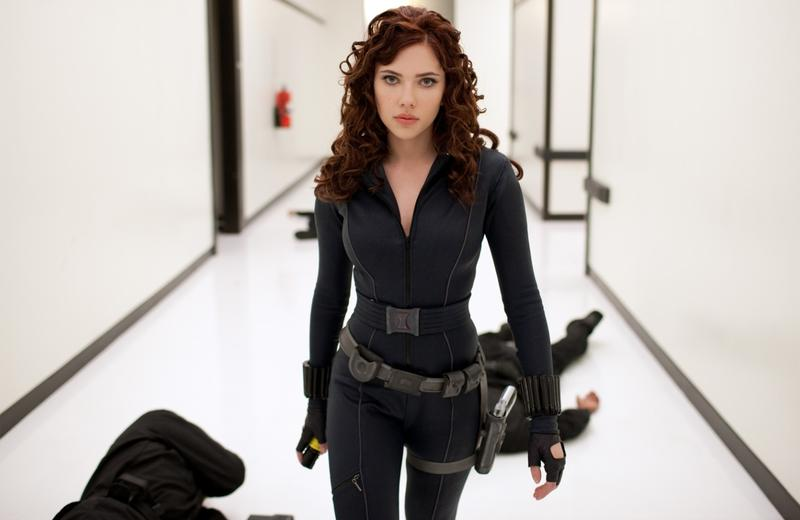What could be the significance of the white corridor with black lines in the character's narrative? The stark white corridor with geometric black lines serves not only as an immediate visual contrast to the character's dark attire but also might symbolize the clarity and simplicity of her moral and ethical framework. This minimalistic approach could underline the isolation she feels in her path and the straightforward, albeit harsh, choices she faces. 